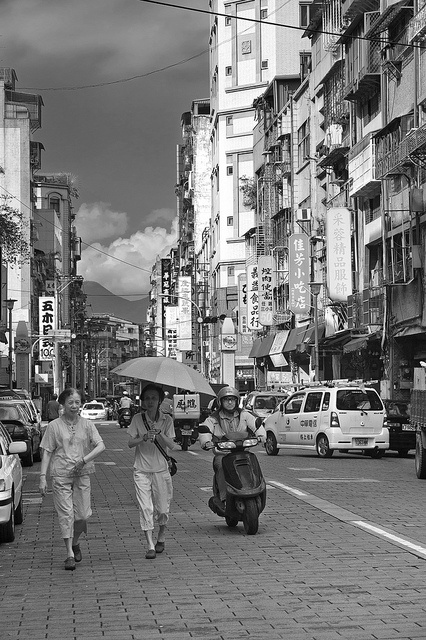Describe the objects in this image and their specific colors. I can see car in gray, darkgray, black, and lightgray tones, people in gray, darkgray, black, and lightgray tones, people in gray, darkgray, black, and lightgray tones, motorcycle in gray, black, darkgray, and lightgray tones, and people in gray, black, darkgray, and lightgray tones in this image. 